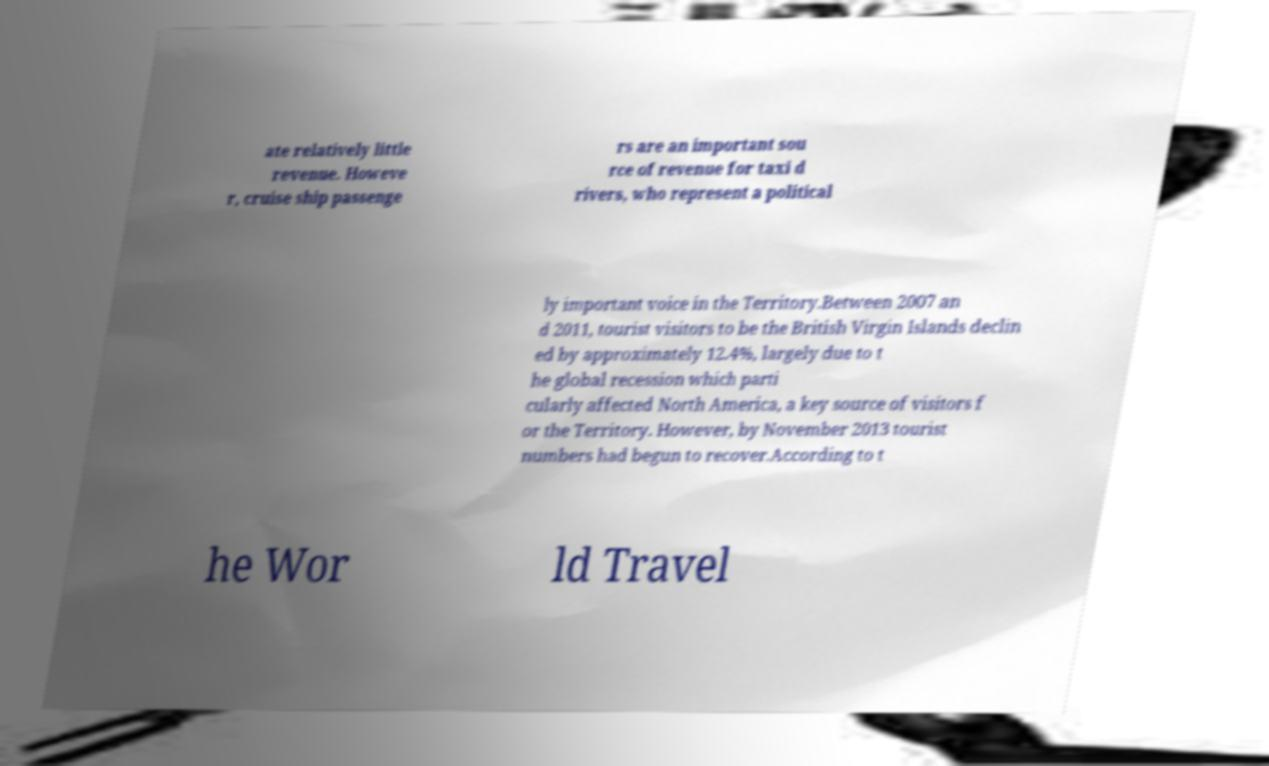Could you extract and type out the text from this image? ate relatively little revenue. Howeve r, cruise ship passenge rs are an important sou rce of revenue for taxi d rivers, who represent a political ly important voice in the Territory.Between 2007 an d 2011, tourist visitors to be the British Virgin Islands declin ed by approximately 12.4%, largely due to t he global recession which parti cularly affected North America, a key source of visitors f or the Territory. However, by November 2013 tourist numbers had begun to recover.According to t he Wor ld Travel 